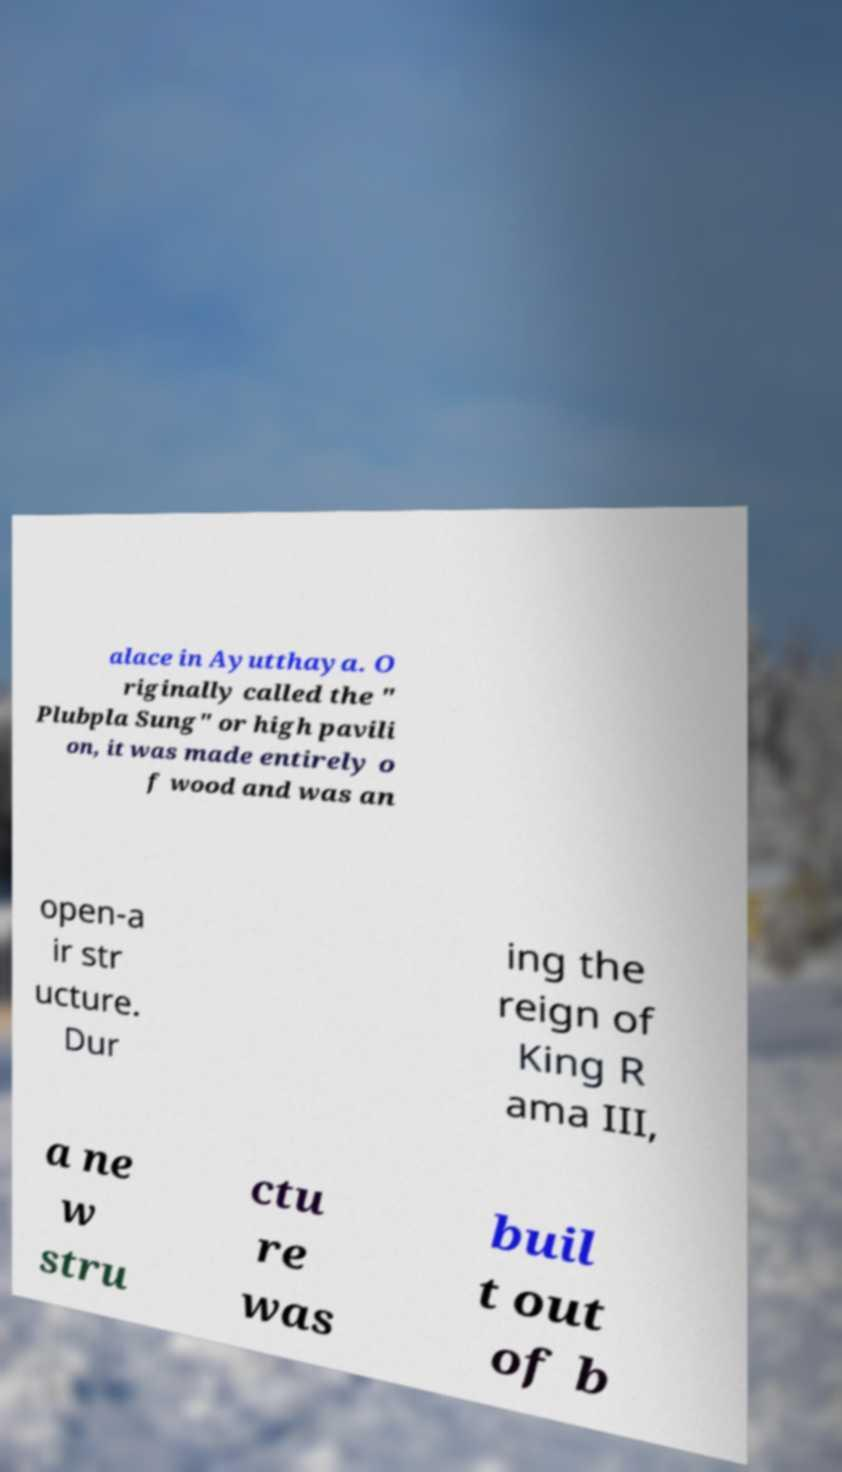Please read and relay the text visible in this image. What does it say? alace in Ayutthaya. O riginally called the " Plubpla Sung" or high pavili on, it was made entirely o f wood and was an open-a ir str ucture. Dur ing the reign of King R ama III, a ne w stru ctu re was buil t out of b 